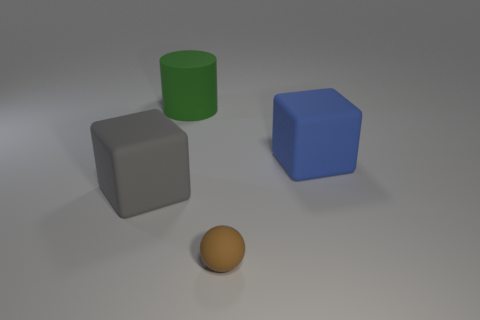There is another thing that is the same shape as the blue thing; what is its color?
Your answer should be very brief. Gray. Are there fewer large gray rubber cylinders than tiny things?
Provide a succinct answer. Yes. There is a brown matte ball; does it have the same size as the block to the left of the large green rubber cylinder?
Your response must be concise. No. What is the color of the rubber thing behind the matte cube behind the gray object?
Provide a succinct answer. Green. How many objects are cubes to the right of the green rubber cylinder or big matte cubes that are right of the rubber cylinder?
Give a very brief answer. 1. Does the blue block have the same size as the brown matte ball?
Your answer should be compact. No. Is there any other thing that has the same size as the gray object?
Give a very brief answer. Yes. Do the thing behind the blue cube and the rubber object that is left of the big cylinder have the same shape?
Provide a short and direct response. No. What size is the brown sphere?
Give a very brief answer. Small. What material is the block that is in front of the big rubber block that is behind the large matte block that is to the left of the large green object?
Provide a short and direct response. Rubber. 